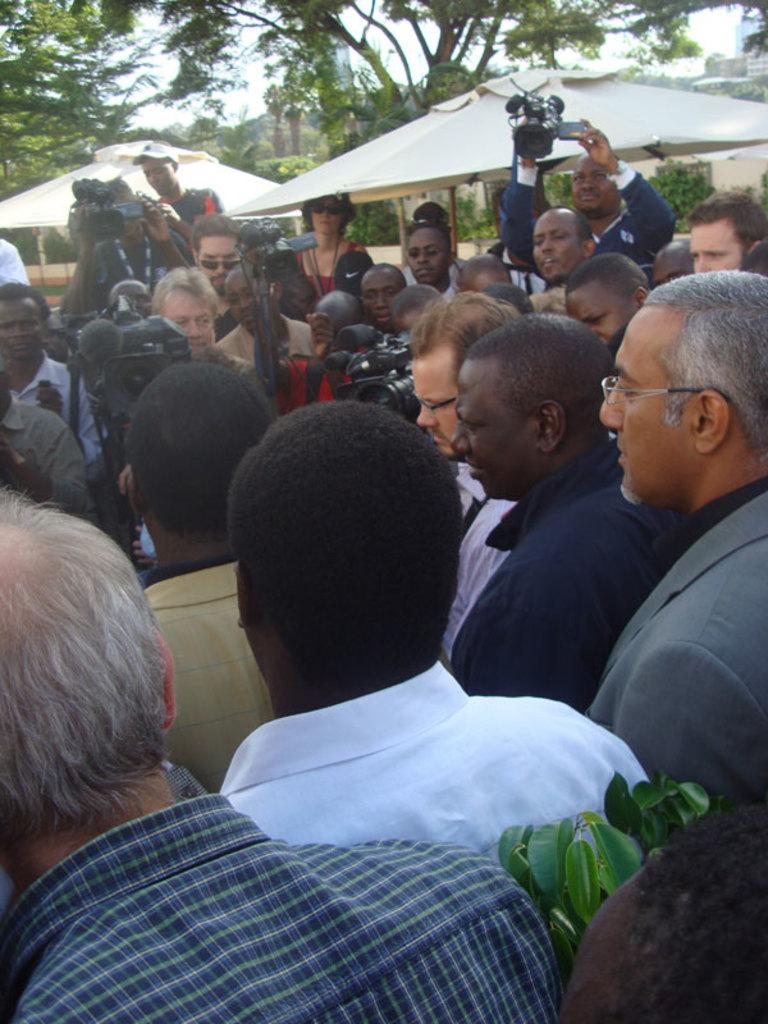How many tents can be seen in the image? There are two tents in the image. What type of structure is also present in the image? There is a building in the image. What architectural feature is visible in the image? There is a wall in the image. What type of vegetation is present in the image? There are trees in the image. What are some of the people in the image doing? Some persons are holding video cameras. What is visible at the top of the image? The sky is visible at the top of the image. What is the level of anger displayed by the trees in the image? There is no indication of anger in the image, as trees are inanimate objects and cannot display emotions. What fact can be determined about the rail system in the image? There is no mention of a rail system in the image, so no fact can be determined about it. 